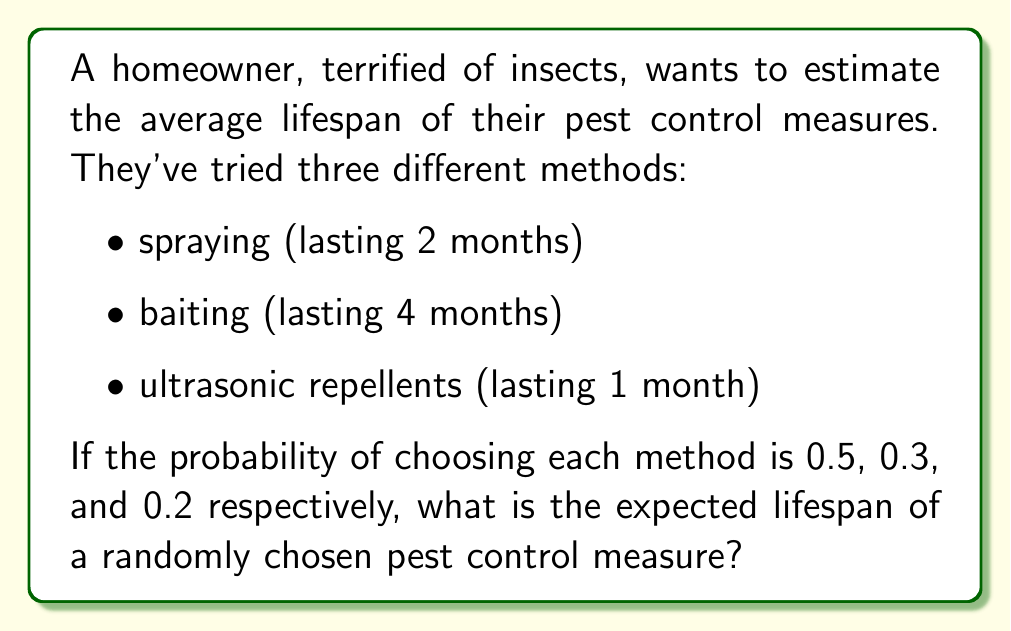Show me your answer to this math problem. Let's approach this step-by-step:

1) Define the random variable X as the lifespan of a randomly chosen pest control measure.

2) We have three possible outcomes:
   - Spraying: X = 2 months, P(X = 2) = 0.5
   - Baiting: X = 4 months, P(X = 4) = 0.3
   - Ultrasonic repellents: X = 1 month, P(X = 1) = 0.2

3) The expected value of a discrete random variable is given by:

   $$E(X) = \sum_{i=1}^{n} x_i \cdot P(X = x_i)$$

   where $x_i$ are the possible values of X and P(X = $x_i$) is the probability of X taking the value $x_i$.

4) Substituting our values:

   $$E(X) = 2 \cdot 0.5 + 4 \cdot 0.3 + 1 \cdot 0.2$$

5) Calculate:

   $$E(X) = 1 + 1.2 + 0.2 = 2.4$$

Therefore, the expected lifespan of a randomly chosen pest control measure is 2.4 months.
Answer: 2.4 months 